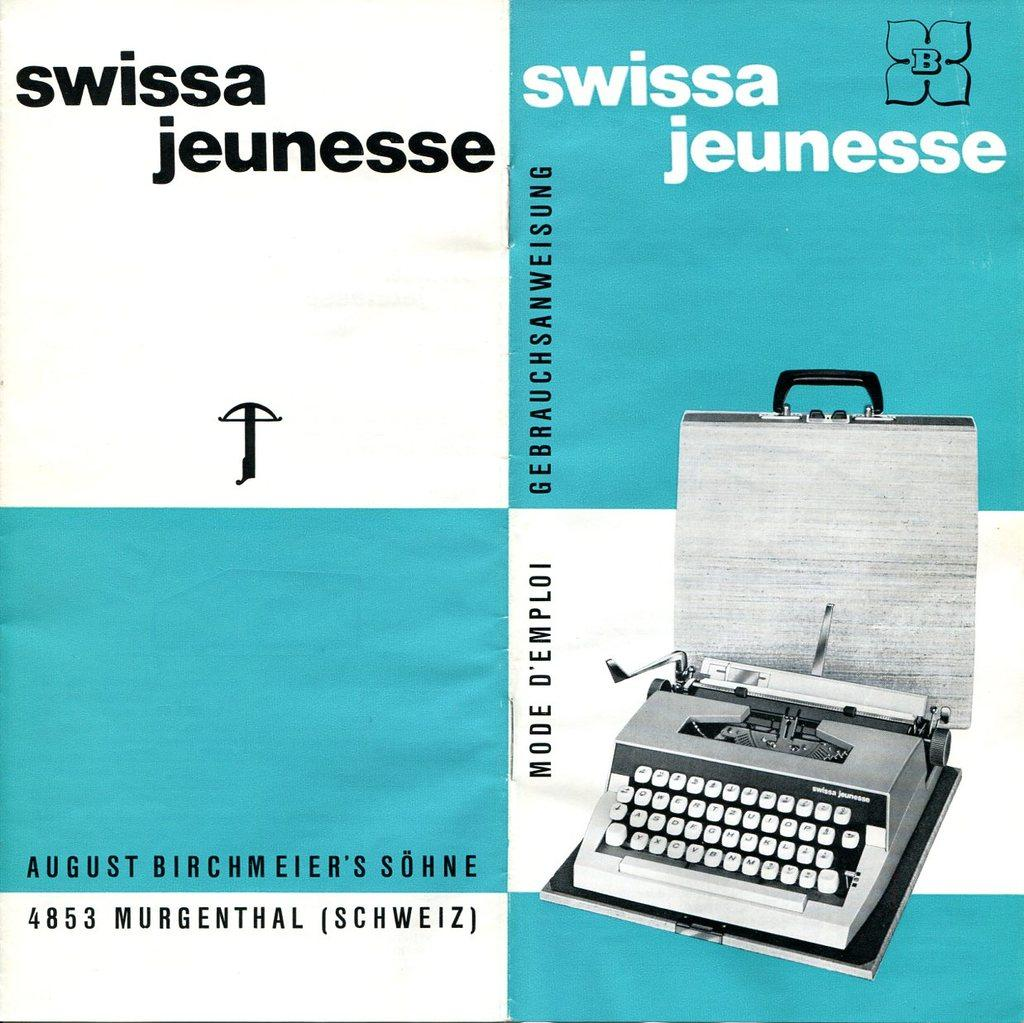What is present in the image that features an image and text? There is a poster in the image that has an image and text printed on it. Can you describe the image on the poster? Unfortunately, the specific image on the poster cannot be described without additional information. What type of information is conveyed through the text on the poster? The content of the text on the poster cannot be determined without additional information. What type of degree is being awarded to the army personnel in the image? There is no degree or army personnel present in the image; it only features a poster with an image and text. 